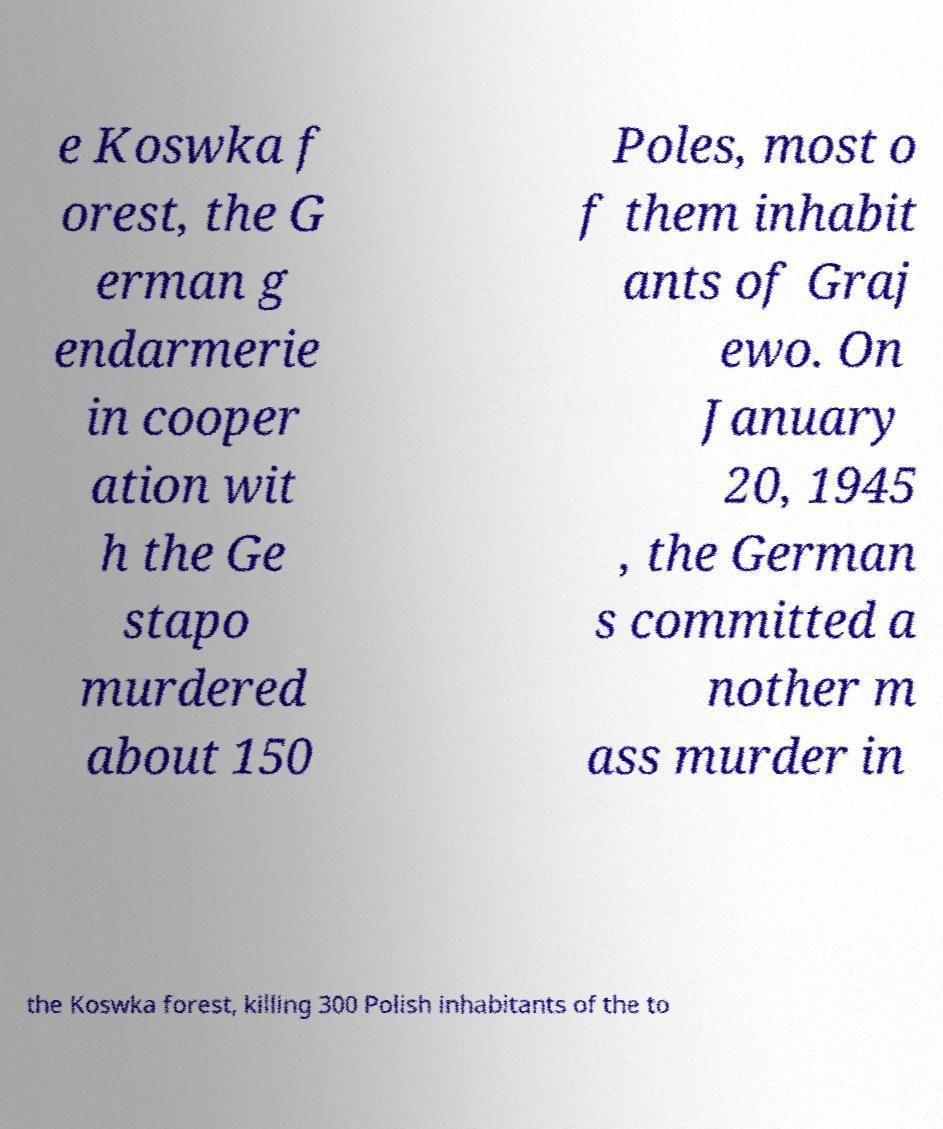Could you extract and type out the text from this image? e Koswka f orest, the G erman g endarmerie in cooper ation wit h the Ge stapo murdered about 150 Poles, most o f them inhabit ants of Graj ewo. On January 20, 1945 , the German s committed a nother m ass murder in the Koswka forest, killing 300 Polish inhabitants of the to 